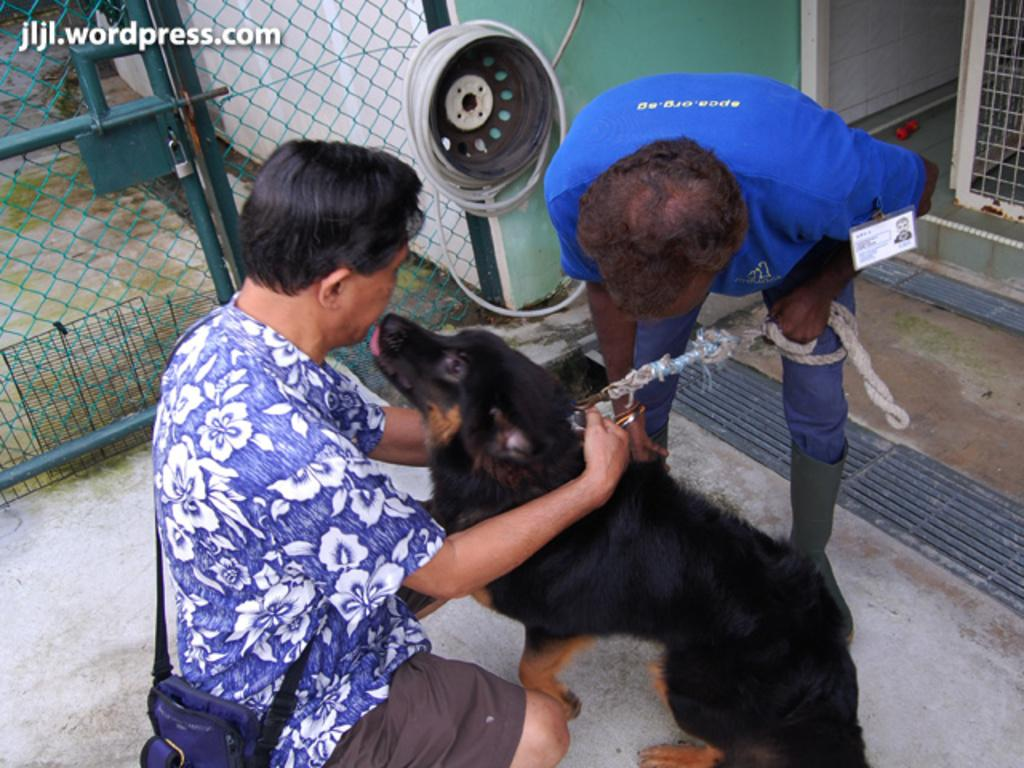How many people are present in the image? There are two persons in the image. What other living creature is present in the image? There is a dog in the image. What can be seen in the background of the image? There is a building in the background of the image. What type of door is visible in the image? There is a mesh door in the image. Is there any text visible in the image? Yes, there is some text visible in the image. What type of scarf is the duck wearing in the image? There is no duck present in the image, and therefore no scarf can be observed. 